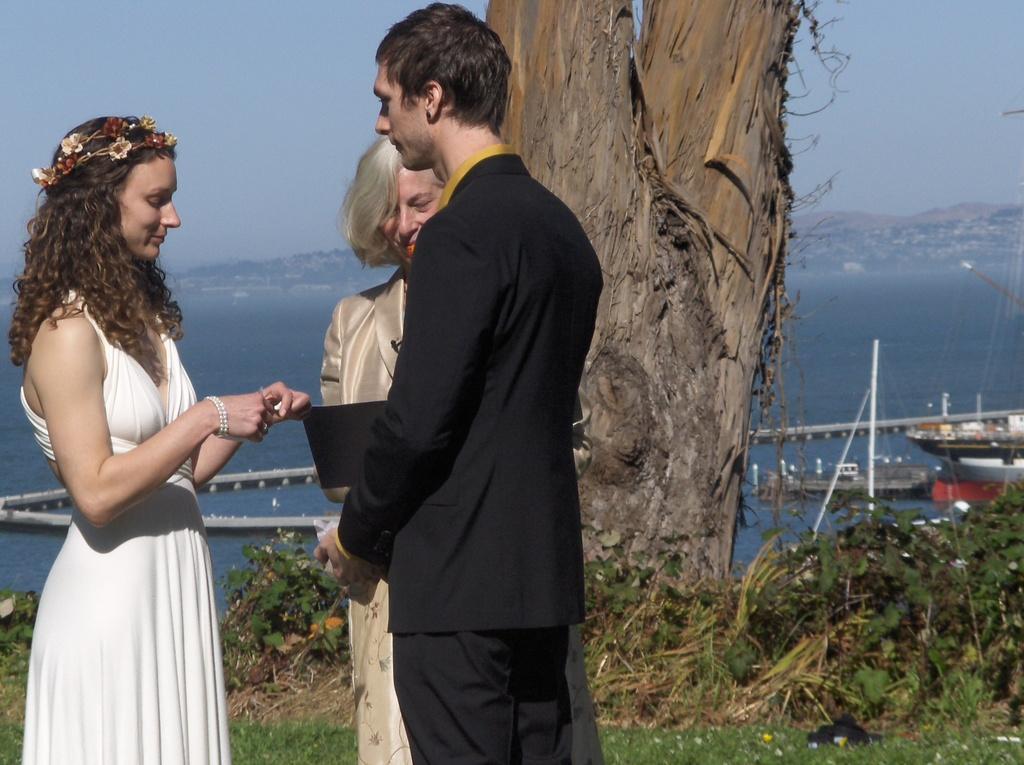In one or two sentences, can you explain what this image depicts? In this picture I can see there is a woman standing here on the left wearing a white dress and there is a woman standing here wearing a black blazer and in the backdrop there is a woman standing here and there is a river, mountain, trees and the sky is clear. 